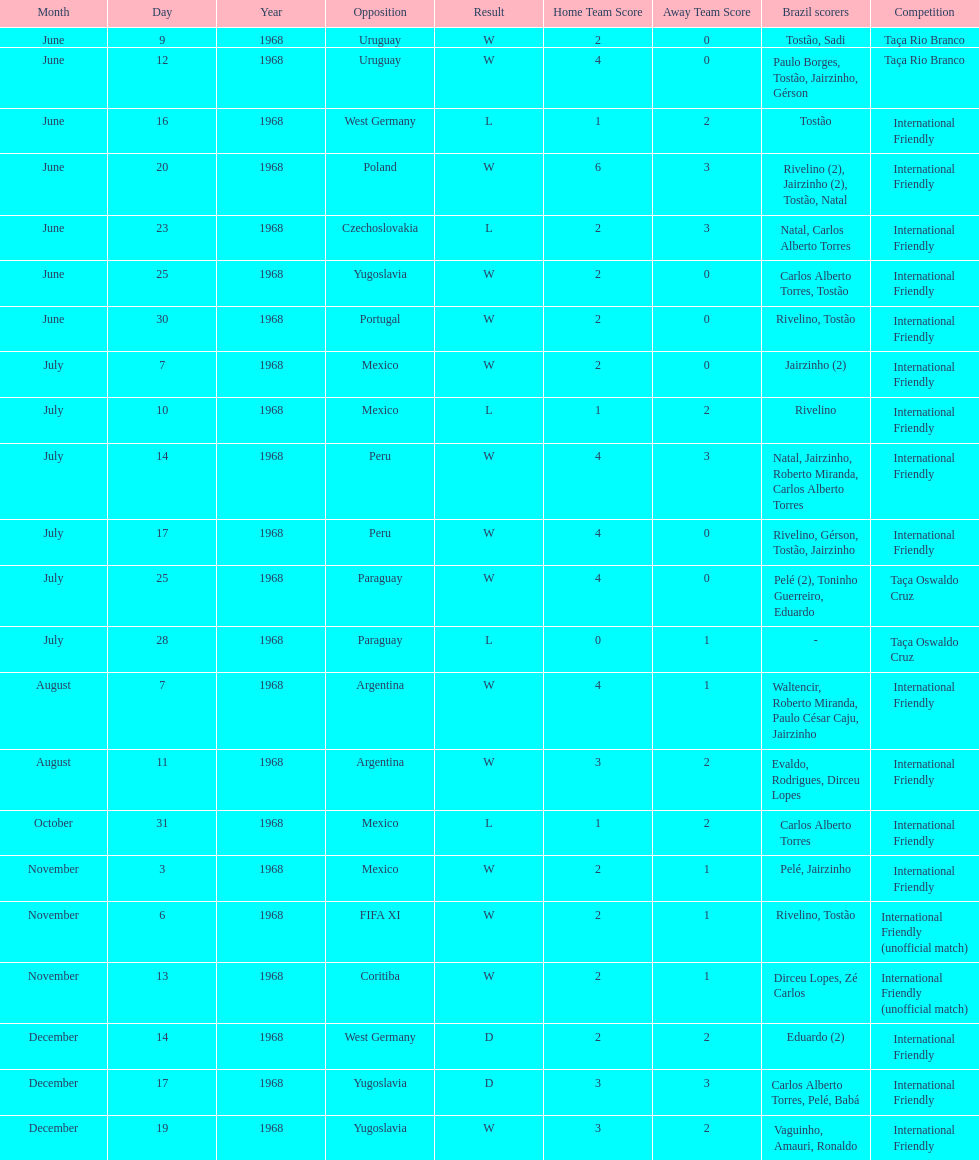Who played brazil previous to the game on june 30th? Yugoslavia. 